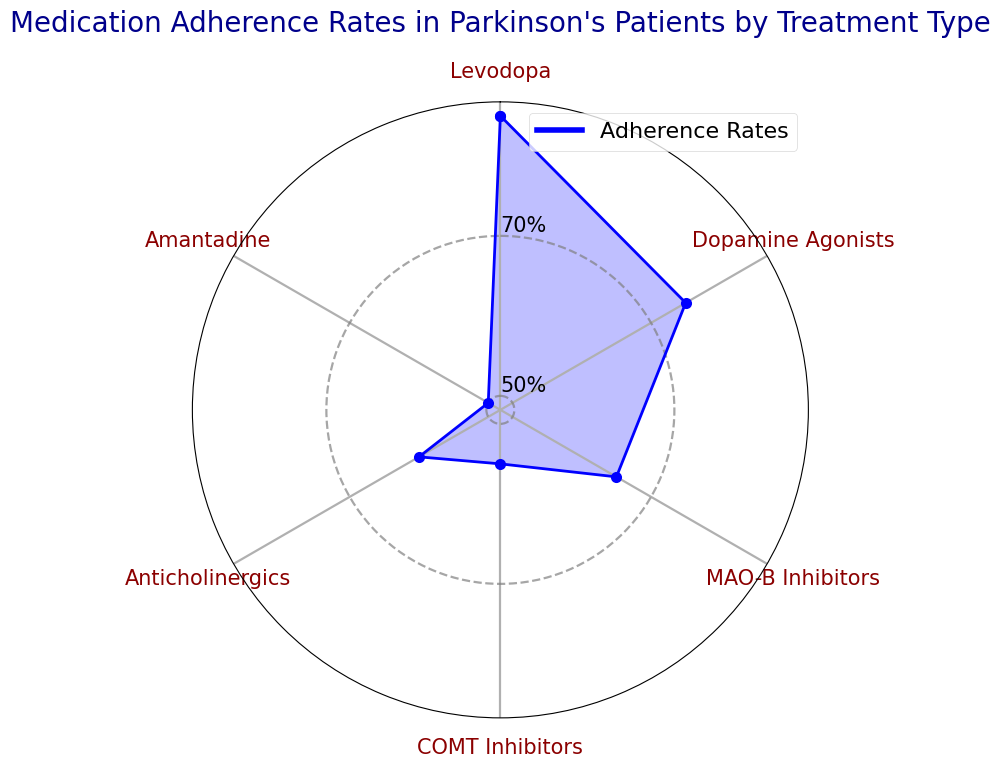Which treatment type has the highest adherence rate? The blue line in the rose chart indicates the adherence rates for each treatment. The highest point on the line corresponds to Levodopa.
Answer: Levodopa Which treatment type has the lowest adherence rate? The lowest point on the blue line in the rose chart corresponds to Amantadine.
Answer: Amantadine What is the average adherence rate across all treatment types? Add all the adherence rates: 85 (Levodopa) + 75 (Dopamine Agonists) + 65 (MAO-B Inhibitors) + 55 (COMT Inhibitors) + 60 (Anticholinergics) + 50 (Amantadine) = 390. Then divide by the number of treatments (6). 390/6 = 65.
Answer: 65 How much higher is the adherence rate for Levodopa compared to Amantadine? Levodopa's adherence rate is 85, while Amantadine's is 50. The difference is 85 - 50 = 35.
Answer: 35 Which two treatment types have the closest adherence rates? Dopamine Agonists have an adherence rate of 75, while MAO-B Inhibitors have 65, showing a difference of 10, which is the smallest difference between any two treatments.
Answer: Dopamine Agonists and MAO-B Inhibitors Are there any treatment types with adherence rates below 60%? Check the points on the blue line below the 60% mark. COMT Inhibitors and Amantadine have adherence rates of 55% and 50% respectively, both below 60%.
Answer: COMT Inhibitors and Amantadine Is the adherence rate of MAO-B Inhibitors closer to Anticholinergics or COMT Inhibitors? MAO-B Inhibitors have an adherence rate of 65. The difference with Anticholinergics is 65 - 60 = 5. The difference with COMT Inhibitors is 65 - 55 = 10. Hence, it is closer to Anticholinergics.
Answer: Anticholinergics Rank the treatment types from highest to lowest adherence rates. Based on the adherence rates: Levodopa (85), Dopamine Agonists (75), MAO-B Inhibitors (65), Anticholinergics (60), COMT Inhibitors (55), Amantadine (50).
Answer: Levodopa, Dopamine Agonists, MAO-B Inhibitors, Anticholinergics, COMT Inhibitors, Amantadine What is the median adherence rate among the treatment types? List the adherence rates in order: 50 (Amantadine), 55 (COMT Inhibitors), 60 (Anticholinergics), 65 (MAO-B Inhibitors), 75 (Dopamine Agonists), 85 (Levodopa). The middle values are 60 and 65, so the median is (60 + 65)/2 = 62.5.
Answer: 62.5 